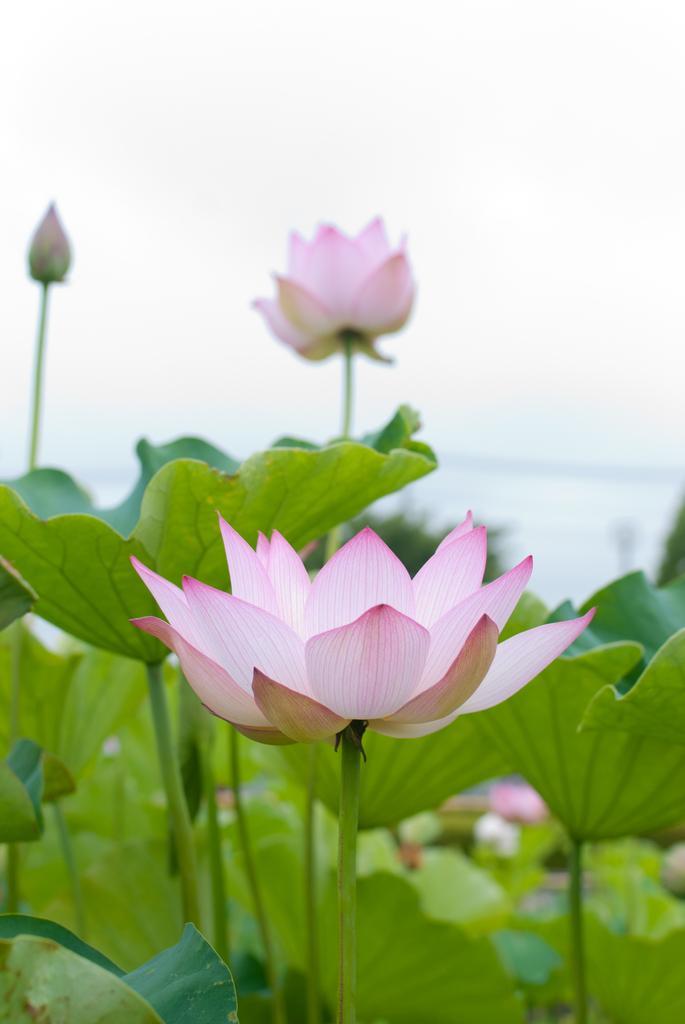Can you describe this image briefly? In this image there are plants with lotus flowers, and there is blur background. 